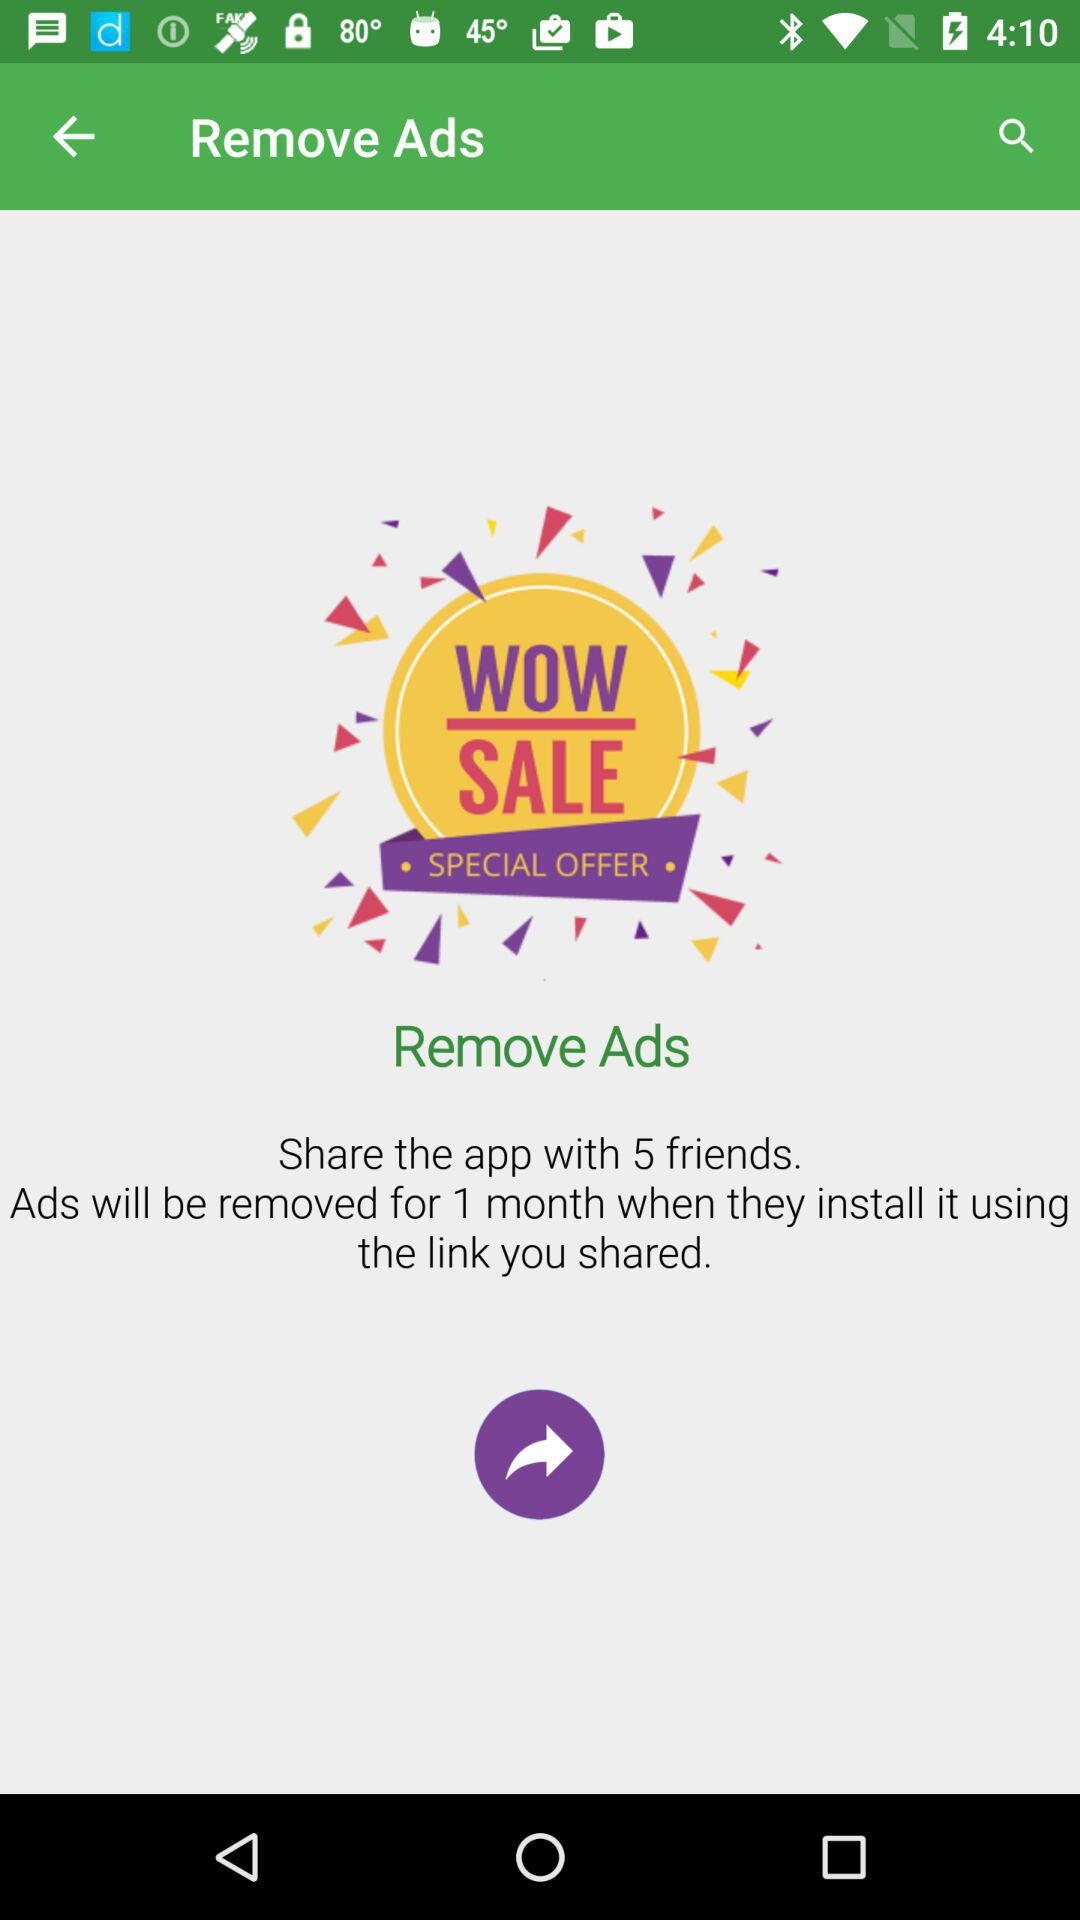For how many months will the ads be removed? The ads will be removed for 1 month. 